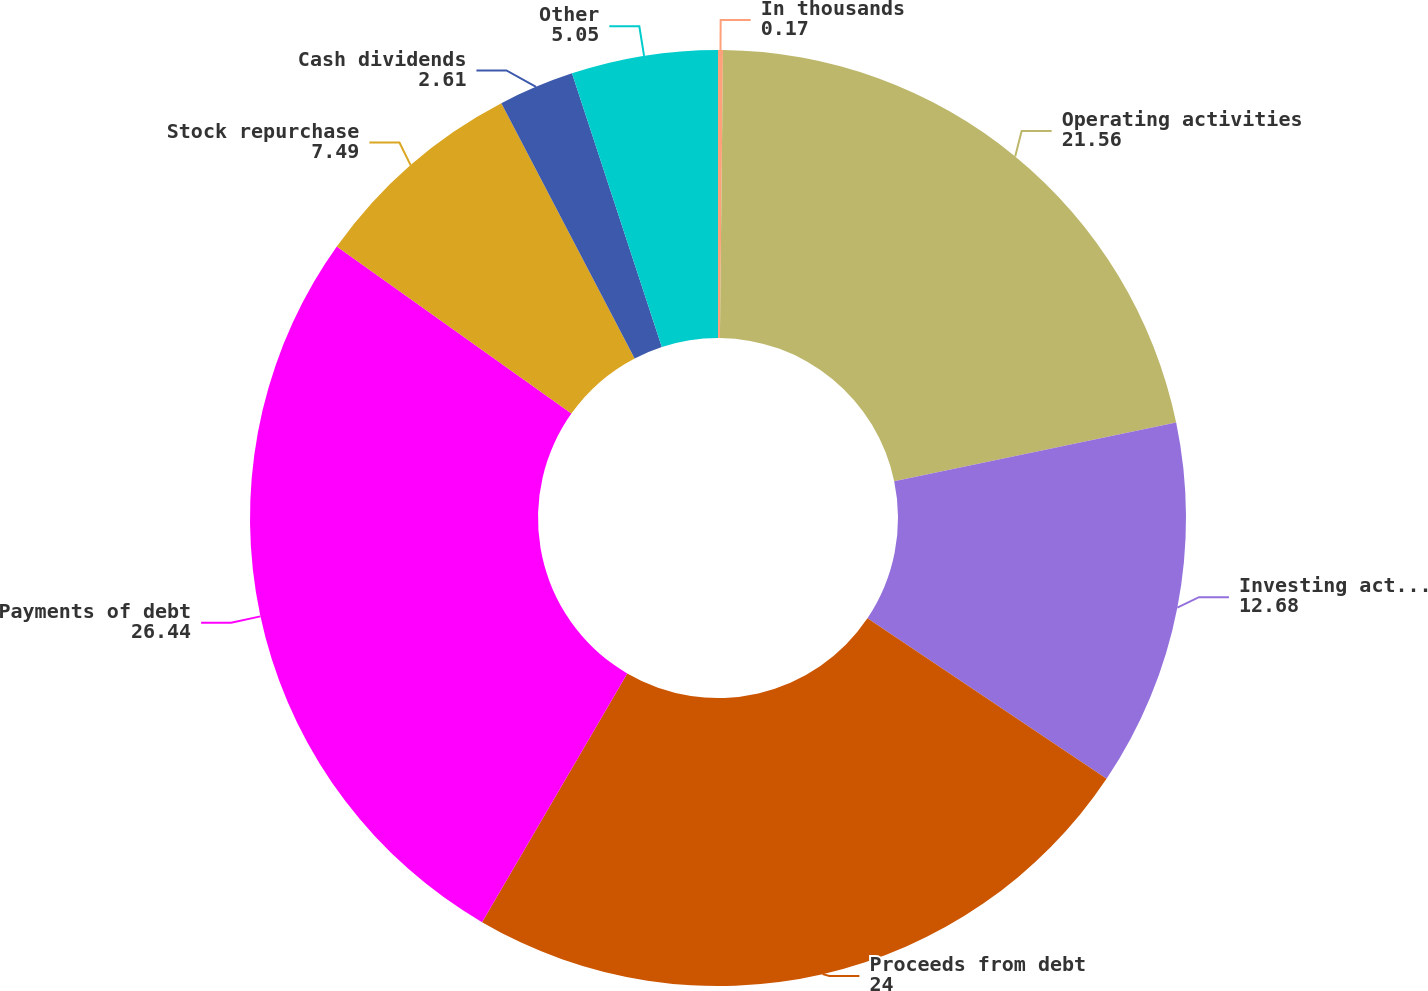Convert chart to OTSL. <chart><loc_0><loc_0><loc_500><loc_500><pie_chart><fcel>In thousands<fcel>Operating activities<fcel>Investing activities<fcel>Proceeds from debt<fcel>Payments of debt<fcel>Stock repurchase<fcel>Cash dividends<fcel>Other<nl><fcel>0.17%<fcel>21.56%<fcel>12.68%<fcel>24.0%<fcel>26.44%<fcel>7.49%<fcel>2.61%<fcel>5.05%<nl></chart> 